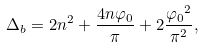Convert formula to latex. <formula><loc_0><loc_0><loc_500><loc_500>\Delta _ { b } = 2 n ^ { 2 } + \frac { 4 n \varphi _ { 0 } } { \pi } + 2 \frac { { \varphi _ { 0 } } ^ { 2 } } { \pi ^ { 2 } } ,</formula> 